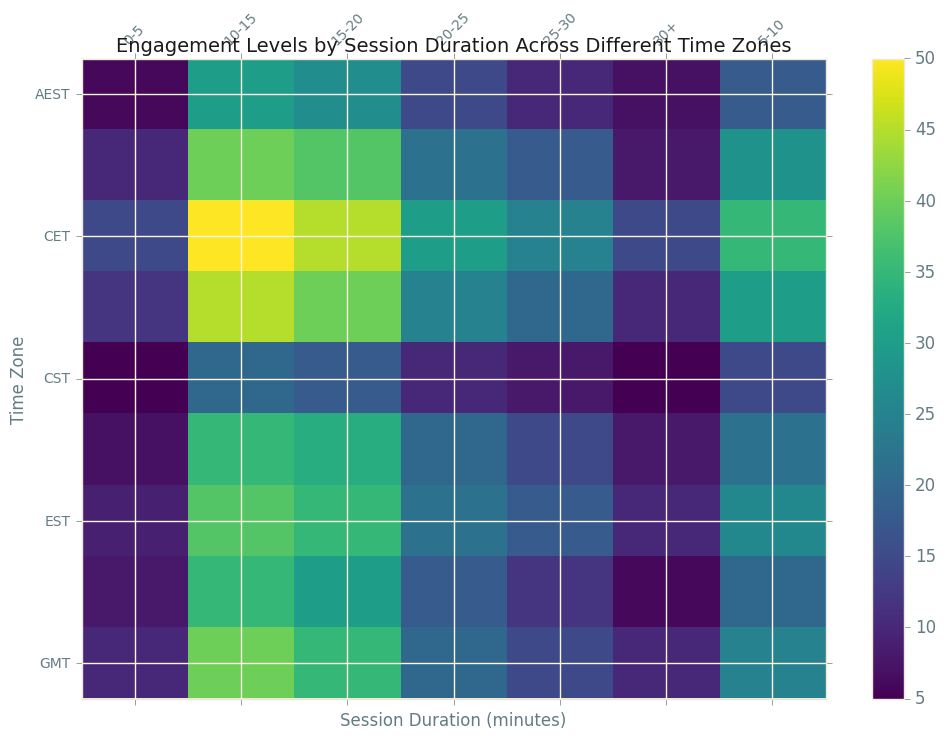Which time zone has the highest engagement level for sessions lasting 10-15 minutes? First, locate the session duration of 10-15 minutes, then find the row with the highest value in that column. CST has the highest engagement of 50.
Answer: CST What is the difference in engagement levels for sessions lasting 15-20 minutes between MST and PST? Identify the engagement levels for MST and PST in the 15-20 minutes column. MST shows 30 while PST shows 35. The difference is 35 - 30 = 5.
Answer: 5 Which time zone consistently shows the lowest engagement levels across all session durations? Visually scan each row for the lowest engagement values. GMT appears consistently lower than the rest.
Answer: GMT Among all time zones, which time zone has the greatest engagement increase between 0-5 and 5-10 minutes session durations? Calculate the difference between the engagement levels of 0-5 and 5-10 minutes for each time zone. CST changes from 15 to 35, which is an increase of 20, the highest among all.
Answer: CST What is the average engagement level for sessions longer than 30 minutes? Extract engagement levels for the 30+ minutes sessions from all time zones and calculate the mean. Values are: 10, 10, 15, 6, 5, 8, 8, 10, 7. Sum them (79) and divide by the number of time zones (9). 79 / 9 = 8.78.
Answer: 8.78 